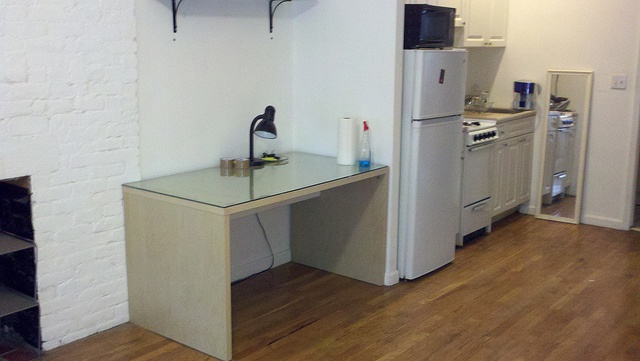Describe the objects in this image and their specific colors. I can see refrigerator in lightgray, darkgray, and gray tones, oven in lightgray, gray, and black tones, microwave in lightgray, black, and gray tones, and bottle in lightgray, darkgray, blue, and gray tones in this image. 